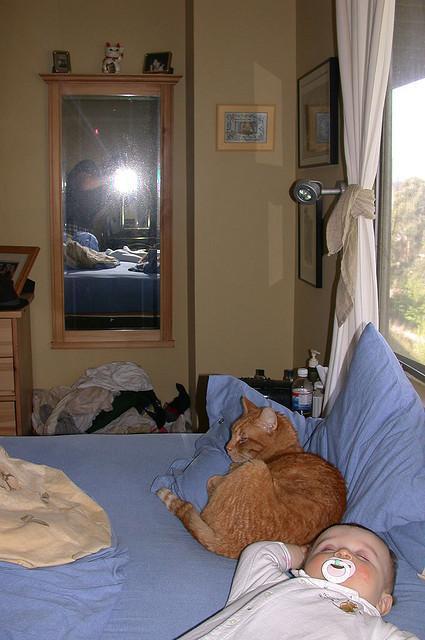What is the cause of the bright spot in the center of the mirror on the wall?
Pick the correct solution from the four options below to address the question.
Options: Lamp, lighter, flashlight, camera flash. Camera flash. 